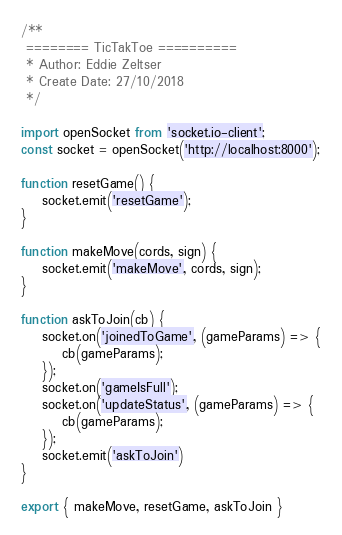Convert code to text. <code><loc_0><loc_0><loc_500><loc_500><_JavaScript_>/**
 ======== TicTakToe ==========
 * Author: Eddie Zeltser
 * Create Date: 27/10/2018
 */

import openSocket from 'socket.io-client';
const socket = openSocket('http://localhost:8000');

function resetGame() {
    socket.emit('resetGame');
}

function makeMove(cords, sign) {
    socket.emit('makeMove', cords, sign);
}

function askToJoin(cb) {
    socket.on('joinedToGame', (gameParams) => {
        cb(gameParams);
    });
    socket.on('gameIsFull');
    socket.on('updateStatus', (gameParams) => {
        cb(gameParams);
    });
    socket.emit('askToJoin')
}

export { makeMove, resetGame, askToJoin }</code> 